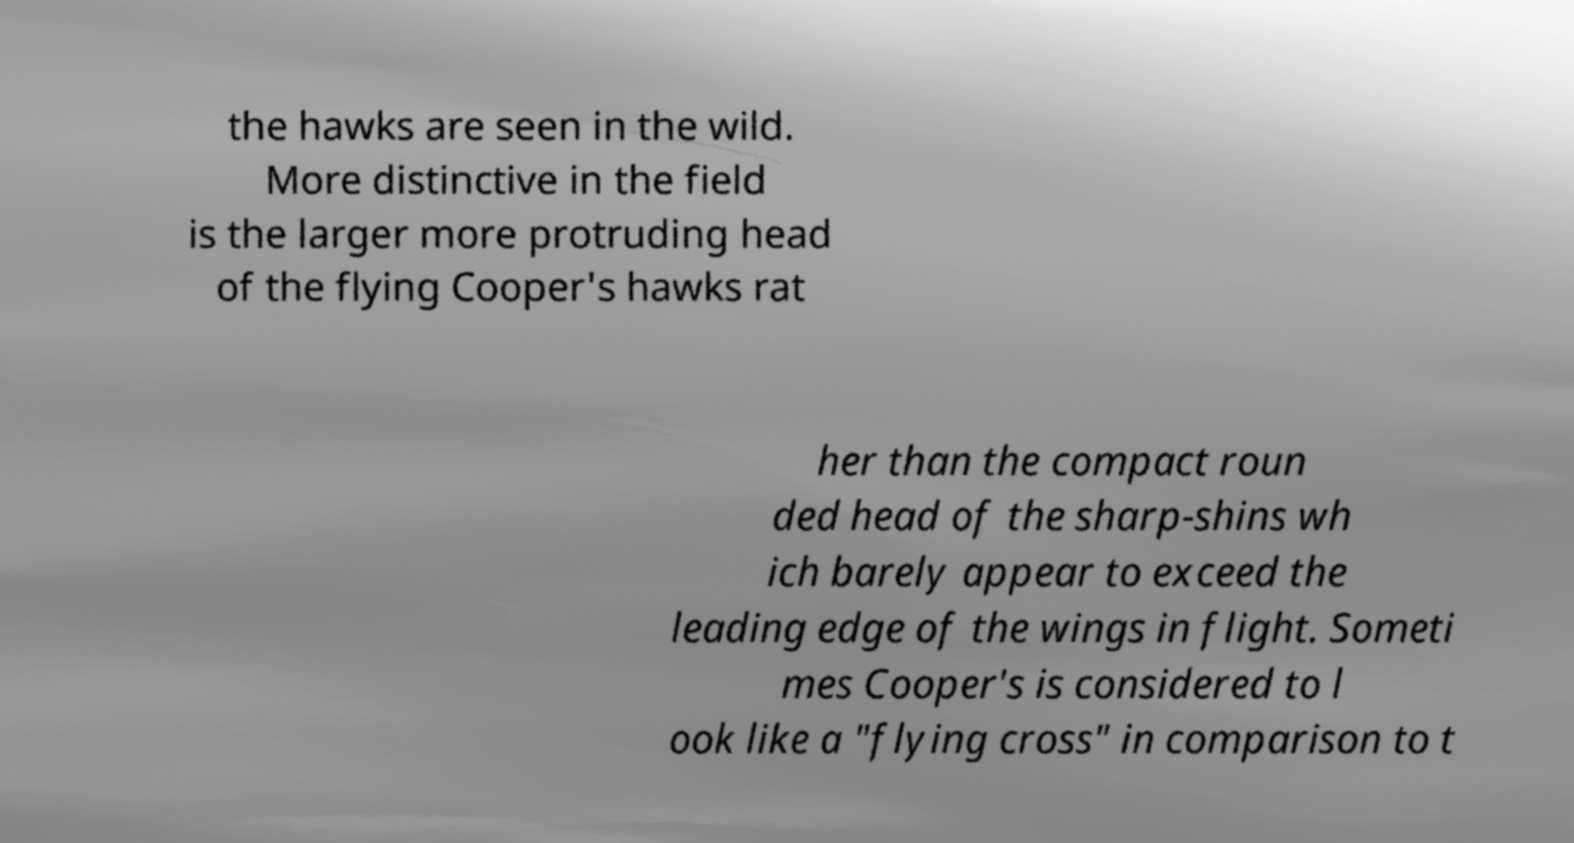Could you assist in decoding the text presented in this image and type it out clearly? the hawks are seen in the wild. More distinctive in the field is the larger more protruding head of the flying Cooper's hawks rat her than the compact roun ded head of the sharp-shins wh ich barely appear to exceed the leading edge of the wings in flight. Someti mes Cooper's is considered to l ook like a "flying cross" in comparison to t 